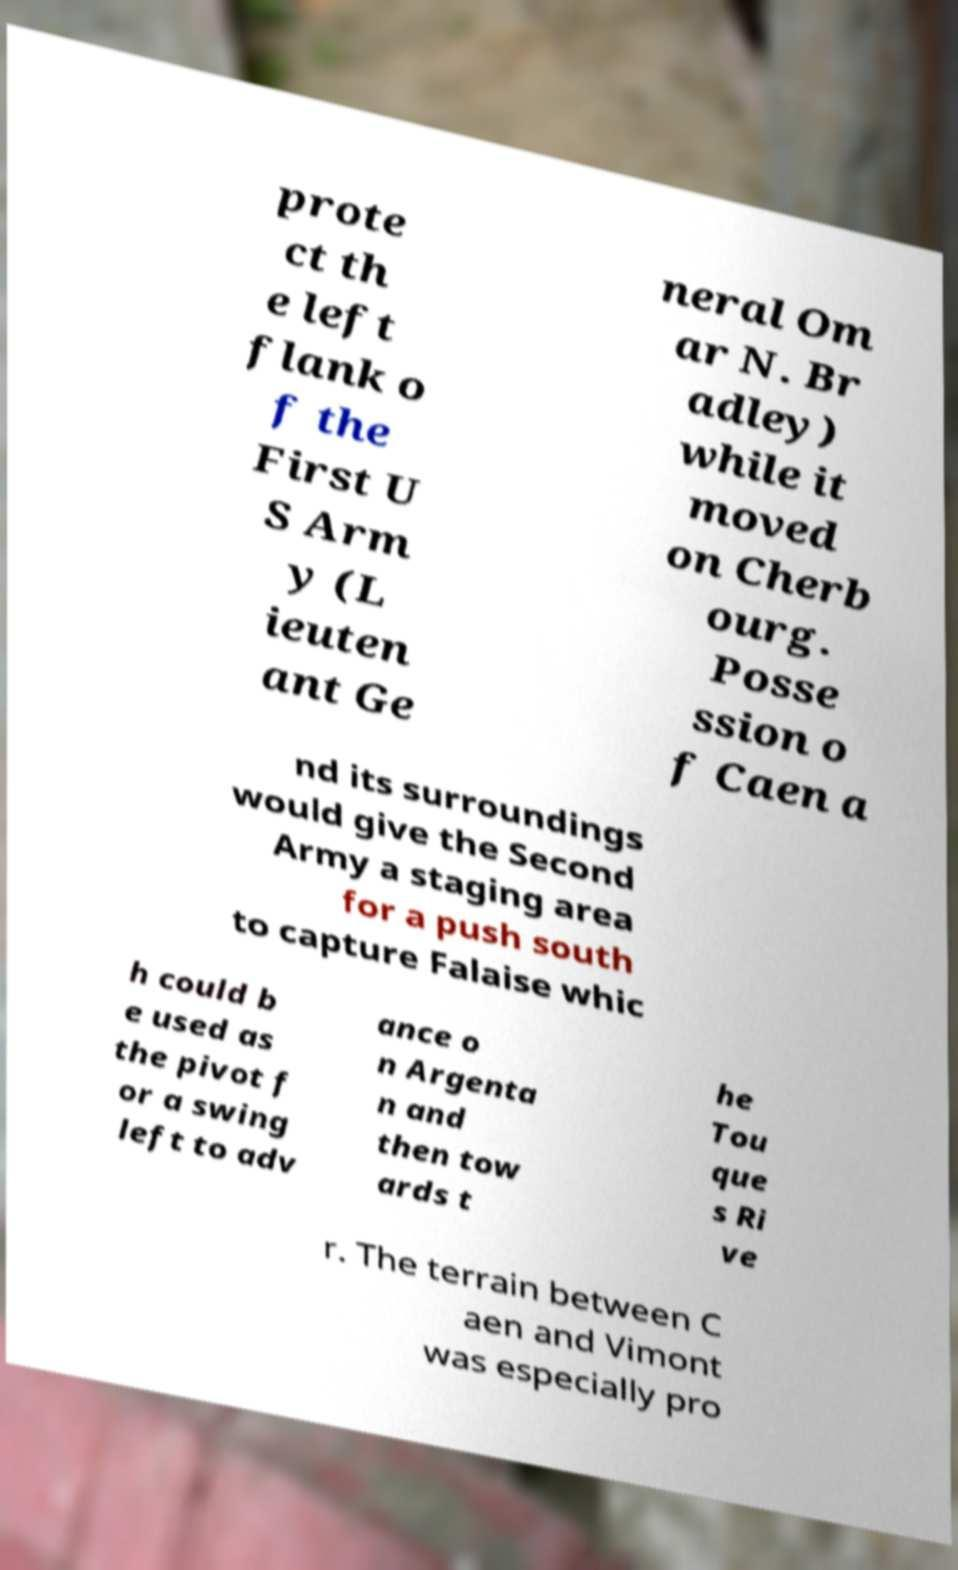Can you read and provide the text displayed in the image?This photo seems to have some interesting text. Can you extract and type it out for me? prote ct th e left flank o f the First U S Arm y (L ieuten ant Ge neral Om ar N. Br adley) while it moved on Cherb ourg. Posse ssion o f Caen a nd its surroundings would give the Second Army a staging area for a push south to capture Falaise whic h could b e used as the pivot f or a swing left to adv ance o n Argenta n and then tow ards t he Tou que s Ri ve r. The terrain between C aen and Vimont was especially pro 